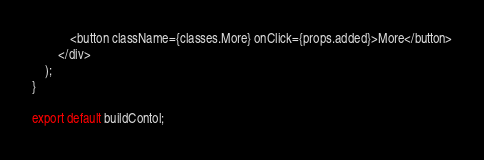<code> <loc_0><loc_0><loc_500><loc_500><_JavaScript_>            <button className={classes.More} onClick={props.added}>More</button>
        </div>
    );
}

export default buildContol;</code> 